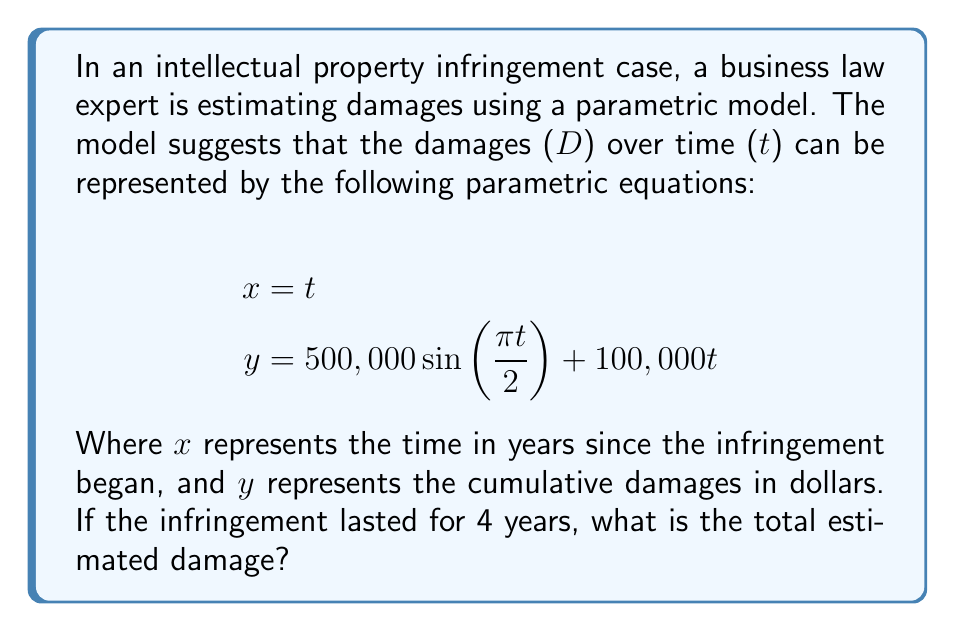What is the answer to this math problem? To solve this problem, we need to follow these steps:

1) First, we need to understand what the parametric equations represent. The $x$ equation simply represents time, while the $y$ equation represents the cumulative damages over time.

2) We're asked to find the total damage after 4 years. This means we need to calculate $y$ when $x = 4$ (or equivalently, when $t = 4$).

3) Let's substitute $t = 4$ into the equation for $y$:

   $$y = 500,000 \sin(\frac{\pi \cdot 4}{2}) + 100,000 \cdot 4$$

4) Let's simplify the sine term first:
   $$\frac{\pi \cdot 4}{2} = 2\pi$$
   $$\sin(2\pi) = 0$$

5) Now our equation looks like:
   $$y = 500,000 \cdot 0 + 100,000 \cdot 4$$

6) Simplify:
   $$y = 0 + 400,000 = 400,000$$

Therefore, the total estimated damage after 4 years is $400,000.

This parametric model combines a cyclical component (the sine function) with a linear growth component. The sine function represents potential fluctuations in damages over time, while the linear term represents a steady increase in damages. In this case, at the 4-year mark, the sine term equals zero, so the total damage is solely determined by the linear component.
Answer: $400,000 